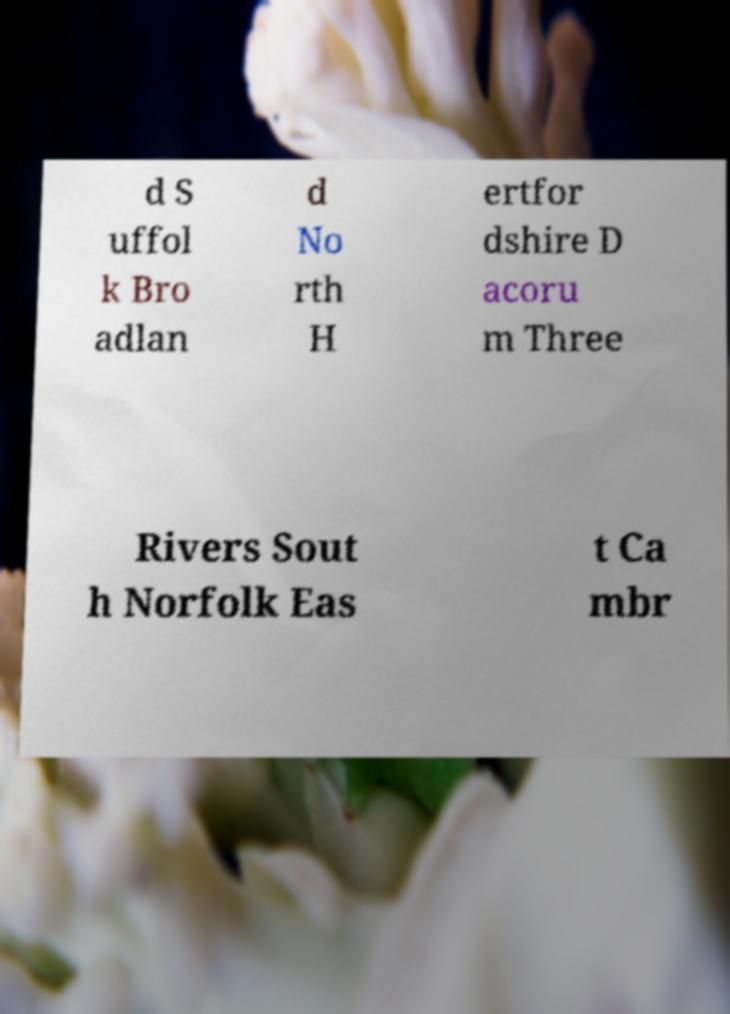I need the written content from this picture converted into text. Can you do that? d S uffol k Bro adlan d No rth H ertfor dshire D acoru m Three Rivers Sout h Norfolk Eas t Ca mbr 